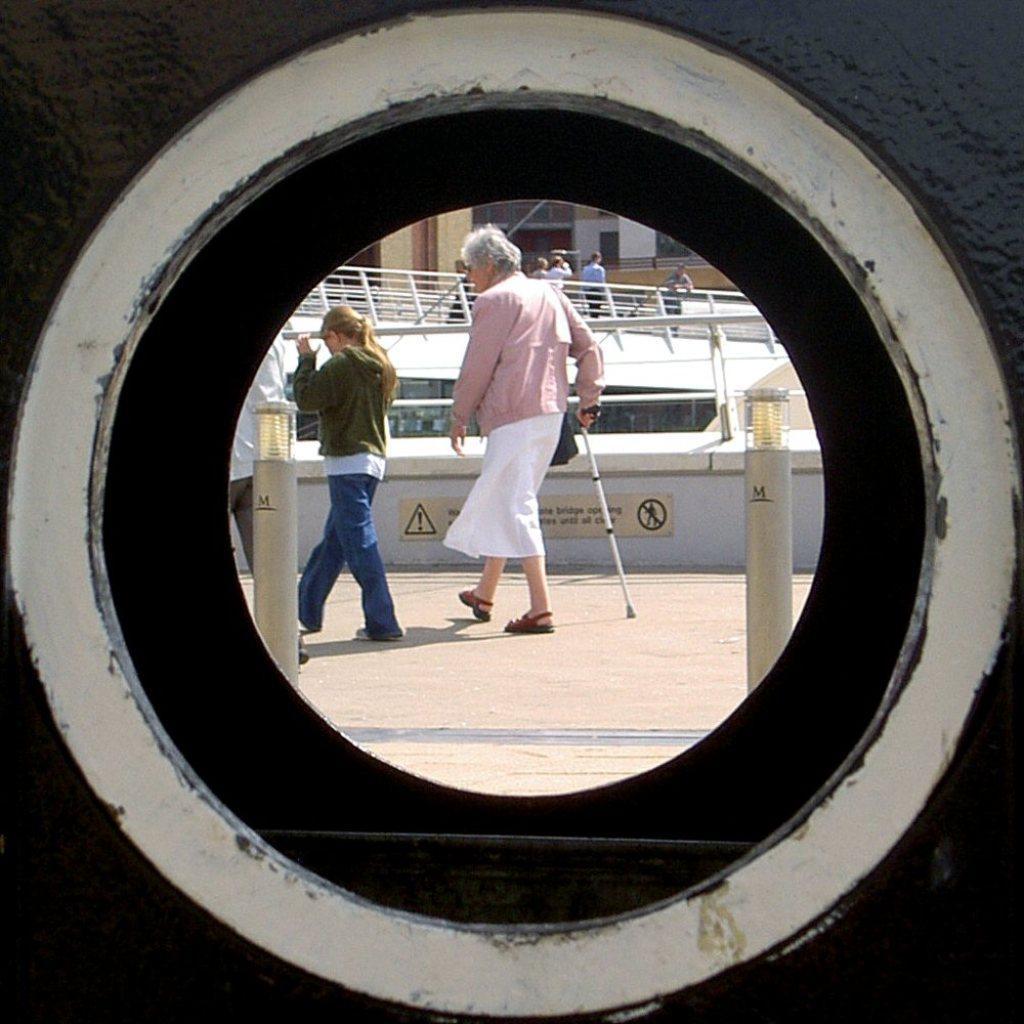How would you summarize this image in a sentence or two? In the foreground of this image, there is a circular mirror like an object in which there are three people walking where a woman is holding a walking stick. In the background it seems like a ship and few people on it. 